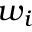Convert formula to latex. <formula><loc_0><loc_0><loc_500><loc_500>w _ { i }</formula> 